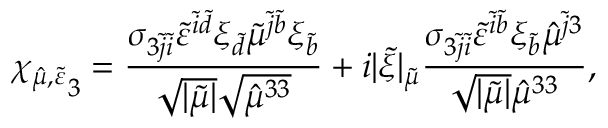<formula> <loc_0><loc_0><loc_500><loc_500>{ \chi _ { \hat { \mu } , \tilde { \varepsilon } } } _ { 3 } = \frac { \sigma _ { 3 \tilde { j } \tilde { i } } \tilde { \varepsilon } ^ { \tilde { i } \tilde { d } } \xi _ { \tilde { d } } \tilde { \mu } ^ { \tilde { j } \tilde { b } } \xi _ { \tilde { b } } } { \sqrt { | \tilde { \mu } | } \sqrt { \hat { \mu } ^ { 3 3 } } } + i | \tilde { \xi } | _ { \tilde { \mu } } \frac { \sigma _ { 3 \tilde { j } \tilde { i } } \tilde { \varepsilon } ^ { \tilde { i } \tilde { b } } \xi _ { \tilde { b } } \hat { \mu } ^ { \tilde { j } 3 } } { \sqrt { | \tilde { \mu } | } \hat { \mu } ^ { 3 3 } } ,</formula> 